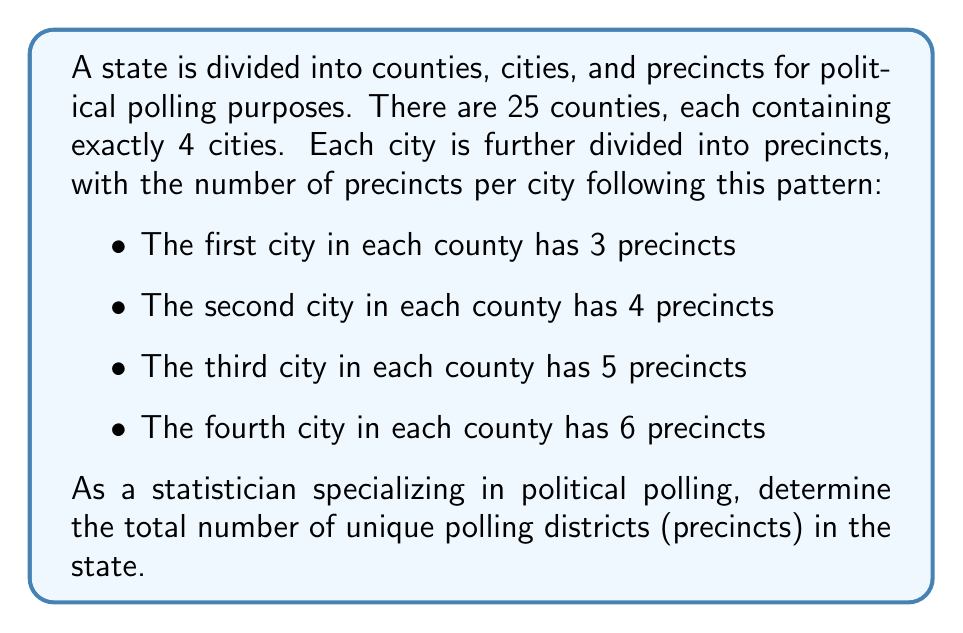Show me your answer to this math problem. To solve this problem, we need to follow these steps:

1. Calculate the total number of cities:
   $$ \text{Total cities} = \text{Number of counties} \times \text{Cities per county} $$
   $$ \text{Total cities} = 25 \times 4 = 100 \text{ cities} $$

2. Calculate the number of precincts for each type of city:
   - First city in each county: 3 precincts
   - Second city in each county: 4 precincts
   - Third city in each county: 5 precincts
   - Fourth city in each county: 6 precincts

3. Calculate the total number of precincts:
   $$ \text{Total precincts} = \text{Number of counties} \times (\text{Precincts in 1st city} + \text{Precincts in 2nd city} + \text{Precincts in 3rd city} + \text{Precincts in 4th city}) $$
   $$ \text{Total precincts} = 25 \times (3 + 4 + 5 + 6) $$
   $$ \text{Total precincts} = 25 \times 18 = 450 \text{ precincts} $$

Therefore, the total number of unique polling districts (precincts) in the state is 450.
Answer: 450 precincts 